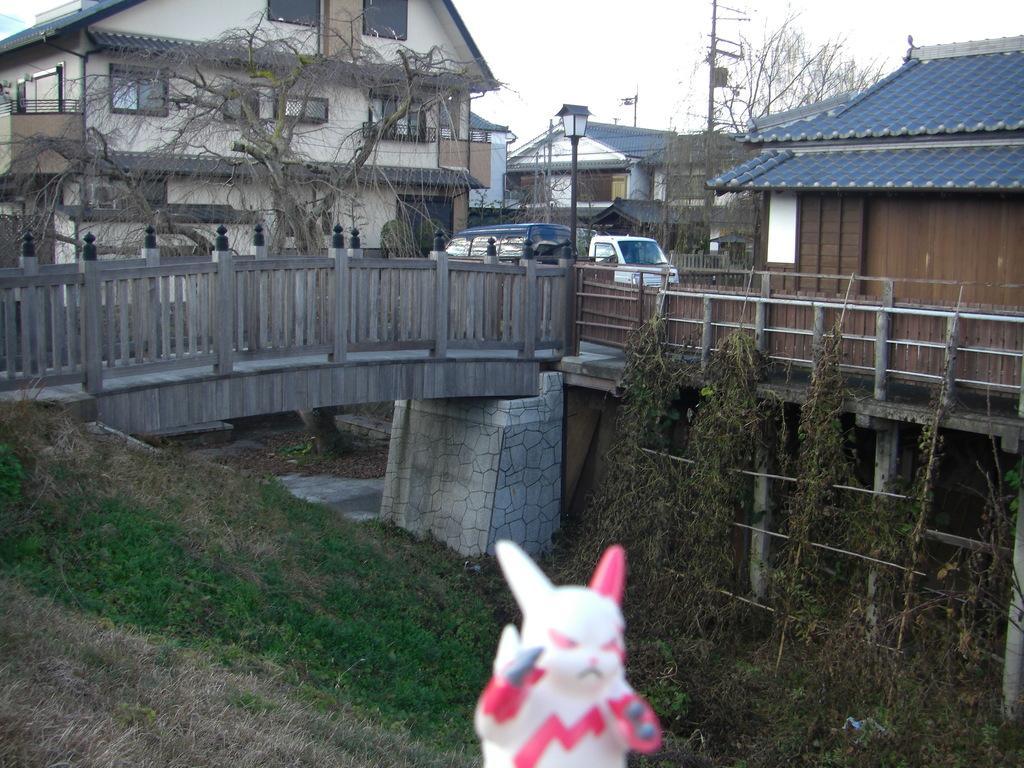Describe this image in one or two sentences. In the image we can see there is a white colour toy and the ground is covered with grass. There is a bridge and vehicles are parked on the road. Behind there are trees and there are buildings. 